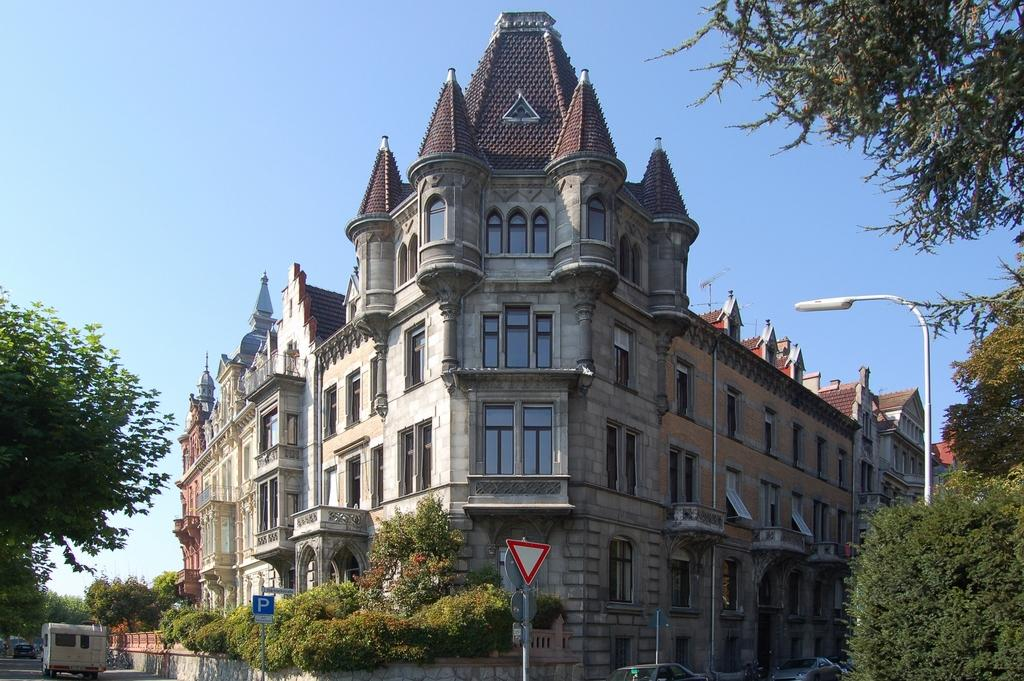What is the main structure in the image? There is a big building in the image. What type of vegetation can be seen on the right side of the image? There are trees on the right side of the image. What is happening on the left side of the image? There is a vehicle moving on the road on the left side of the image. What type of ornament is hanging from the trees on the right side of the image? There are no ornaments hanging from the trees in the image; only trees are present. 